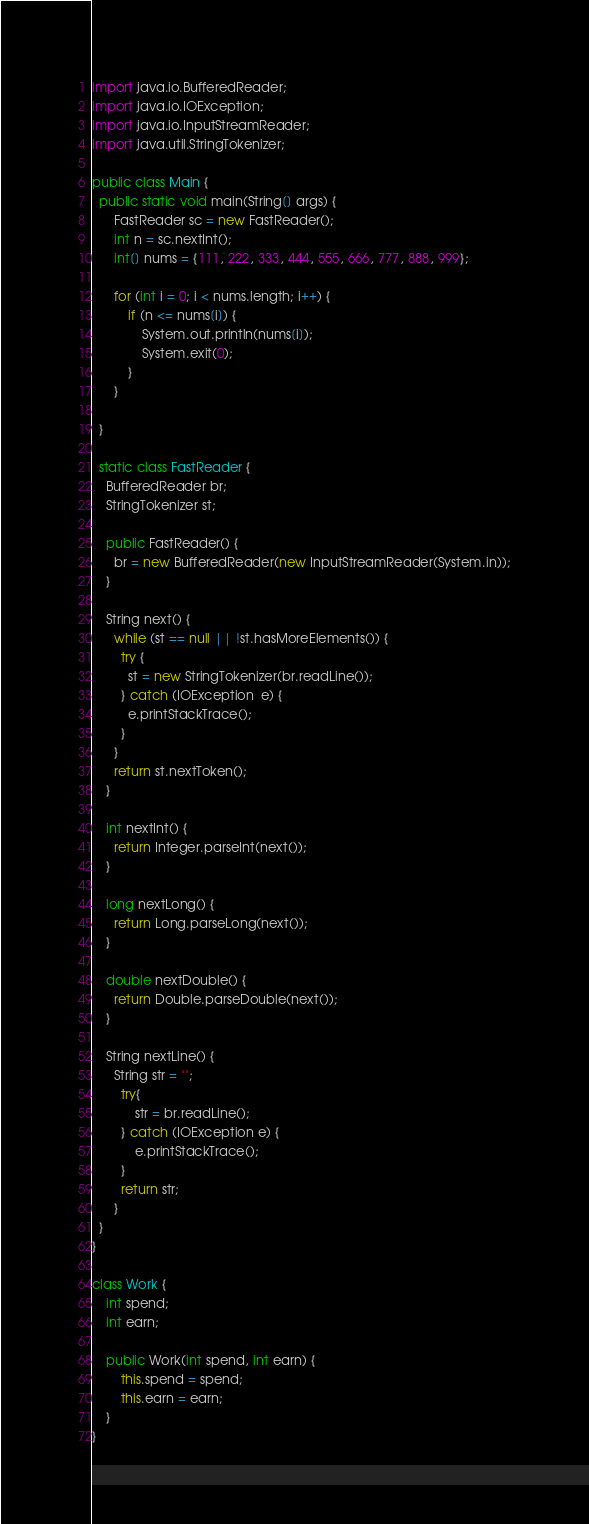<code> <loc_0><loc_0><loc_500><loc_500><_Java_>
import java.io.BufferedReader;
import java.io.IOException;
import java.io.InputStreamReader;
import java.util.StringTokenizer;

public class Main {
  public static void main(String[] args) {
	  FastReader sc = new FastReader();
	  int n = sc.nextInt();
	  int[] nums = {111, 222, 333, 444, 555, 666, 777, 888, 999};
	  
	  for (int i = 0; i < nums.length; i++) {
		  if (n <= nums[i]) {
			  System.out.println(nums[i]);
			  System.exit(0);
		  }
	  }
	  
  }
 
  static class FastReader {
    BufferedReader br;
    StringTokenizer st;

    public FastReader() {
      br = new BufferedReader(new InputStreamReader(System.in));
    }
  
    String next() { 
      while (st == null || !st.hasMoreElements()) {
        try {
          st = new StringTokenizer(br.readLine());
        } catch (IOException  e) {
          e.printStackTrace();
        }
      }
      return st.nextToken();
    }

    int nextInt() {
      return Integer.parseInt(next());
    }

    long nextLong() {
      return Long.parseLong(next());
    }

    double nextDouble() { 
      return Double.parseDouble(next());
    }

    String nextLine() {
      String str = "";
        try{
            str = br.readLine();
        } catch (IOException e) {
            e.printStackTrace();
        }
        return str;
      }
  }
}

class Work {
	int spend;
	int earn;
	
	public Work(int spend, int earn) {
		this.spend = spend;
		this.earn = earn;
	}
}
</code> 